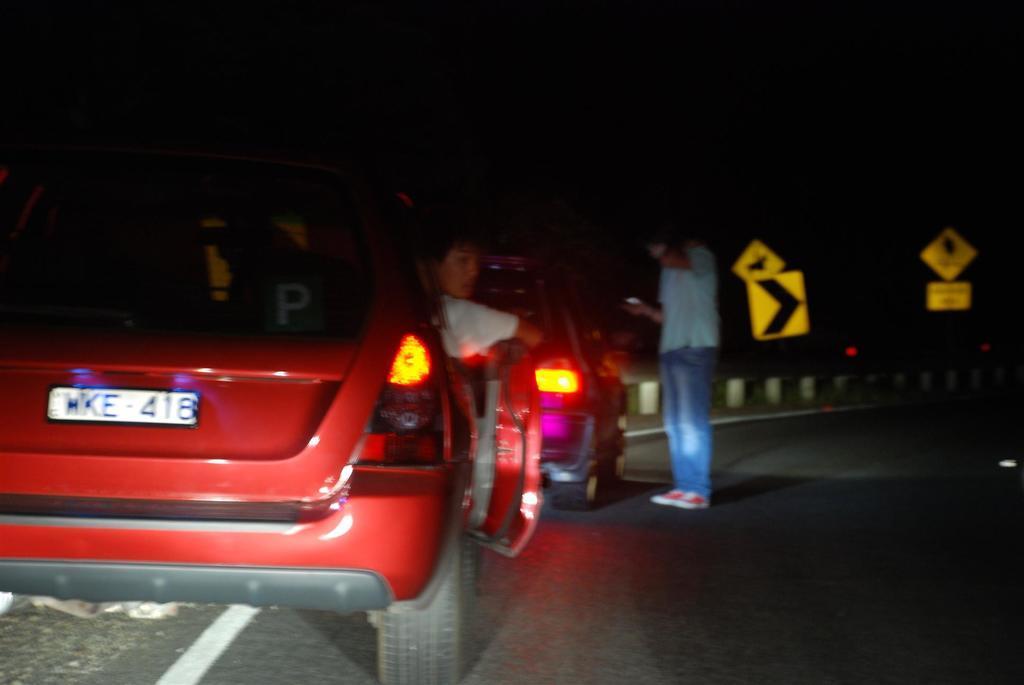Could you give a brief overview of what you see in this image? In this image I can see two vehicles, in one vehicle I can see person and I can see another person standing on road. On the road I can see sign board and this picture is taken during night 